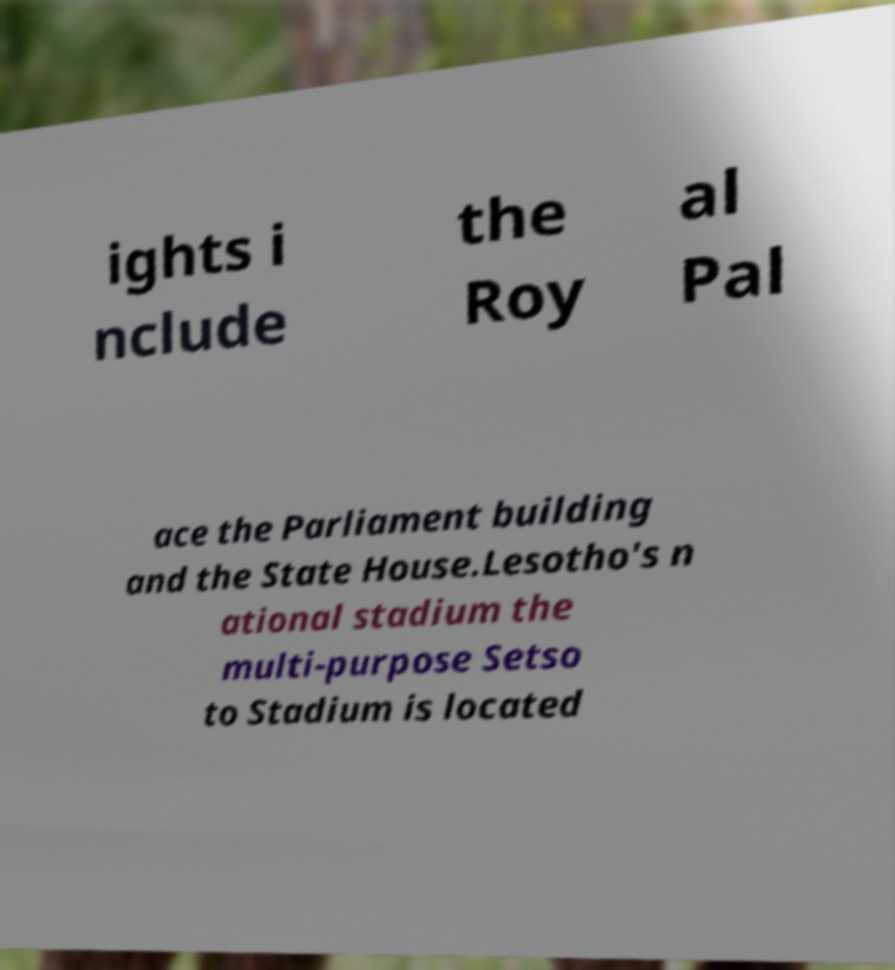There's text embedded in this image that I need extracted. Can you transcribe it verbatim? ights i nclude the Roy al Pal ace the Parliament building and the State House.Lesotho's n ational stadium the multi-purpose Setso to Stadium is located 